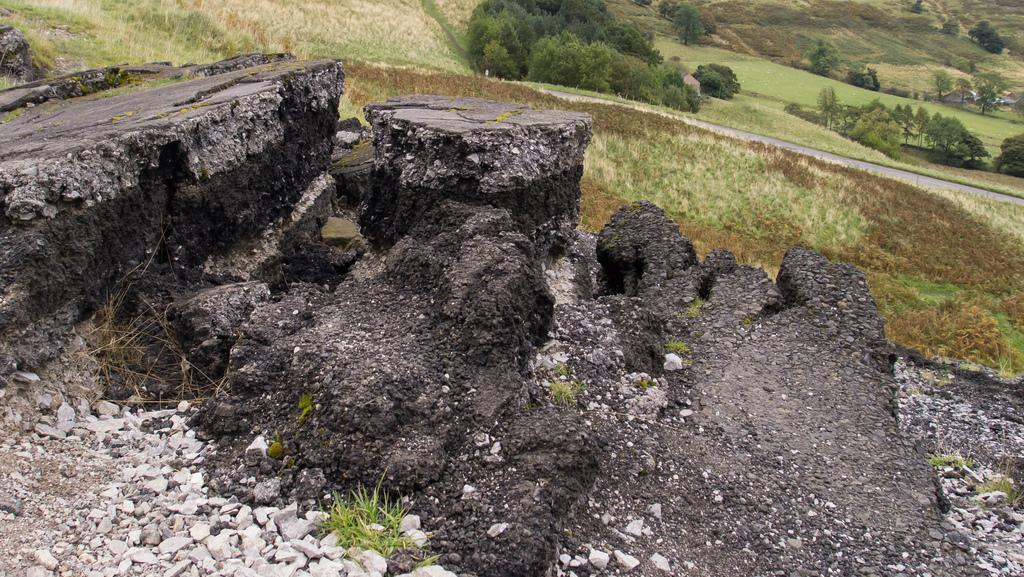What is the condition of the road in the image? The road in the image is broken. What can be seen beside the road? There is greenery ground beside the road. What is visible in the background of the image? There are trees in the background of the image. Where is the library located in the image? There is no library present in the image. What direction is the wind blowing in the image? The image does not provide information about the wind or its direction. 